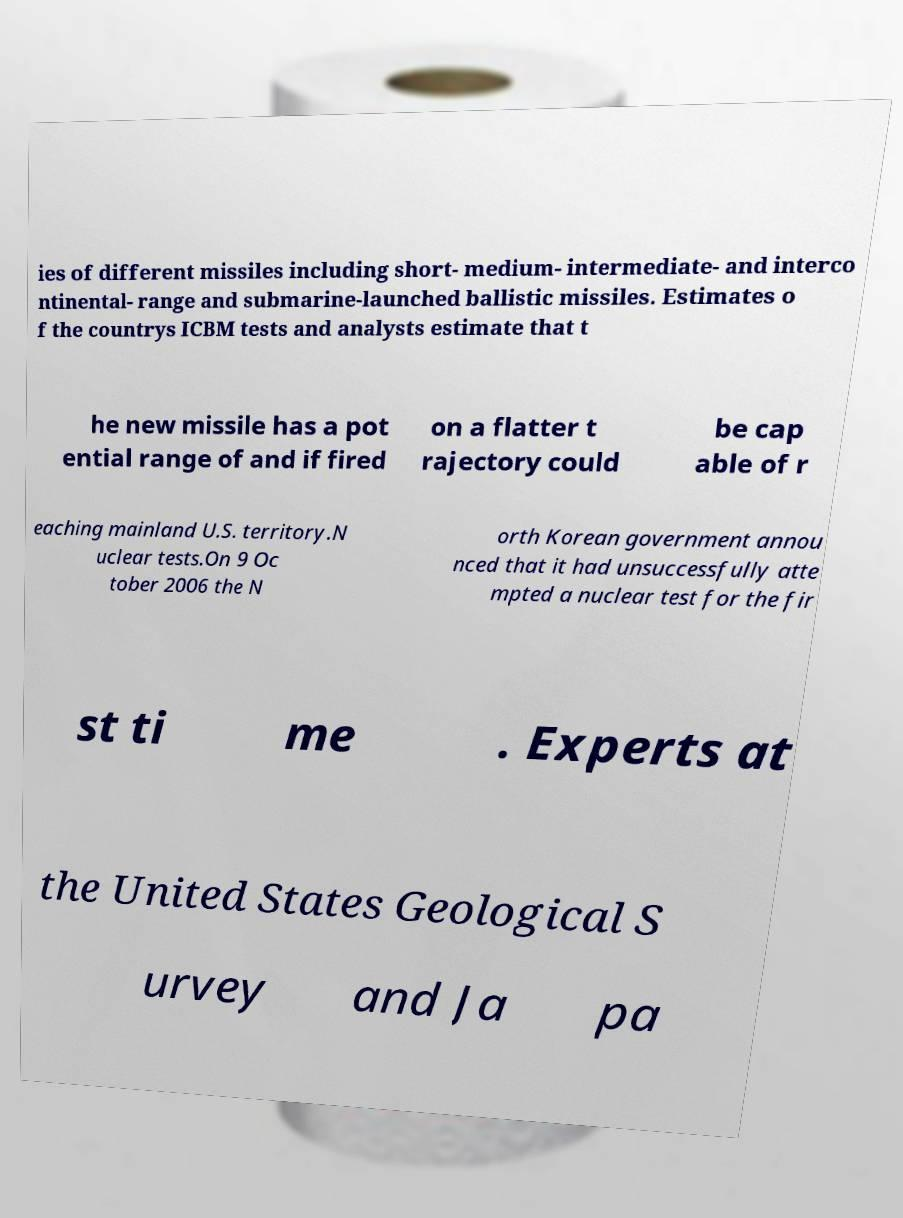Can you read and provide the text displayed in the image?This photo seems to have some interesting text. Can you extract and type it out for me? ies of different missiles including short- medium- intermediate- and interco ntinental- range and submarine-launched ballistic missiles. Estimates o f the countrys ICBM tests and analysts estimate that t he new missile has a pot ential range of and if fired on a flatter t rajectory could be cap able of r eaching mainland U.S. territory.N uclear tests.On 9 Oc tober 2006 the N orth Korean government annou nced that it had unsuccessfully atte mpted a nuclear test for the fir st ti me . Experts at the United States Geological S urvey and Ja pa 